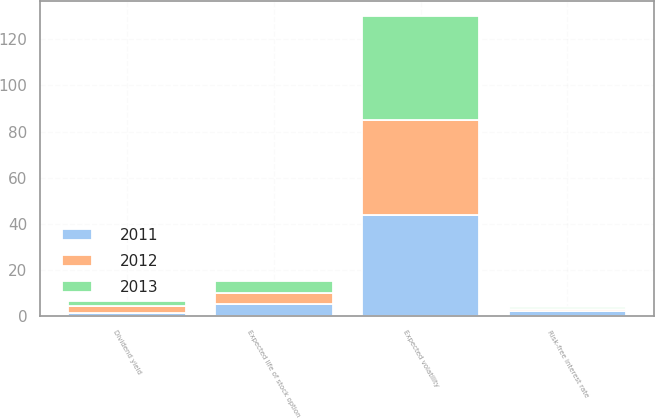Convert chart. <chart><loc_0><loc_0><loc_500><loc_500><stacked_bar_chart><ecel><fcel>Dividend yield<fcel>Expected volatility<fcel>Risk-free interest rate<fcel>Expected life of stock option<nl><fcel>2012<fcel>3<fcel>41<fcel>0.9<fcel>5<nl><fcel>2013<fcel>2<fcel>45<fcel>0.8<fcel>5<nl><fcel>2011<fcel>1.3<fcel>44<fcel>2.3<fcel>5<nl></chart> 